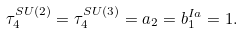<formula> <loc_0><loc_0><loc_500><loc_500>\tau _ { 4 } ^ { S U ( 2 ) } = \tau _ { 4 } ^ { S U ( 3 ) } = a _ { 2 } = b _ { 1 } ^ { I a } = 1 .</formula> 